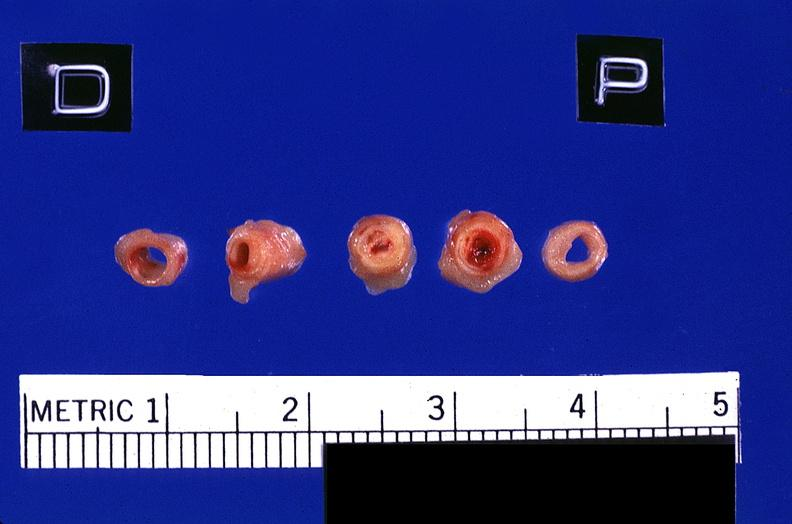does this image show coronary artery with atherosclerosis and thrombotic occlusion?
Answer the question using a single word or phrase. Yes 